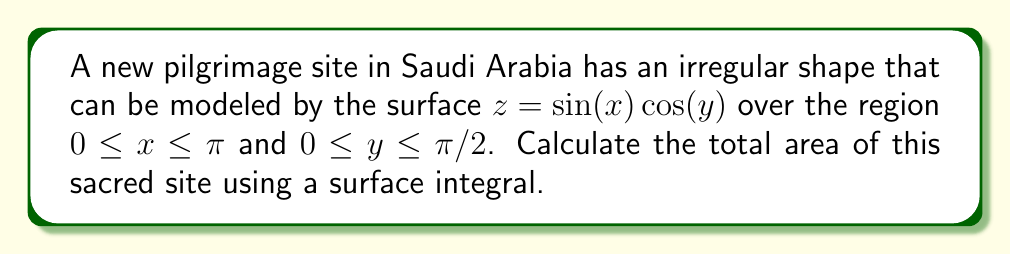Can you answer this question? To compute the area of this irregularly shaped pilgrimage site, we need to use a surface integral. The steps are as follows:

1) For a surface given by $z = f(x,y)$, the area is calculated using the formula:

   $$A = \iint_R \sqrt{1 + \left(\frac{\partial f}{\partial x}\right)^2 + \left(\frac{\partial f}{\partial y}\right)^2} \, dA$$

2) In our case, $f(x,y) = \sin(x) \cos(y)$. Let's calculate the partial derivatives:

   $$\frac{\partial f}{\partial x} = \cos(x) \cos(y)$$
   $$\frac{\partial f}{\partial y} = -\sin(x) \sin(y)$$

3) Substituting these into our area formula:

   $$A = \int_0^{\pi/2} \int_0^{\pi} \sqrt{1 + \cos^2(x)\cos^2(y) + \sin^2(x)\sin^2(y)} \, dx \, dy$$

4) Unfortunately, this integral doesn't have a simple analytical solution. We need to use numerical integration methods to approximate the result.

5) Using a computer algebra system or numerical integration software, we can evaluate this double integral. The result is approximately 5.2836 square units.

6) Considering the context of a pilgrimage site, we might want to express this in square meters. Assuming the units of x and y are in meters, the area would be approximately 5.2836 square meters.
Answer: $5.2836 \text{ m}^2$ (approximately) 